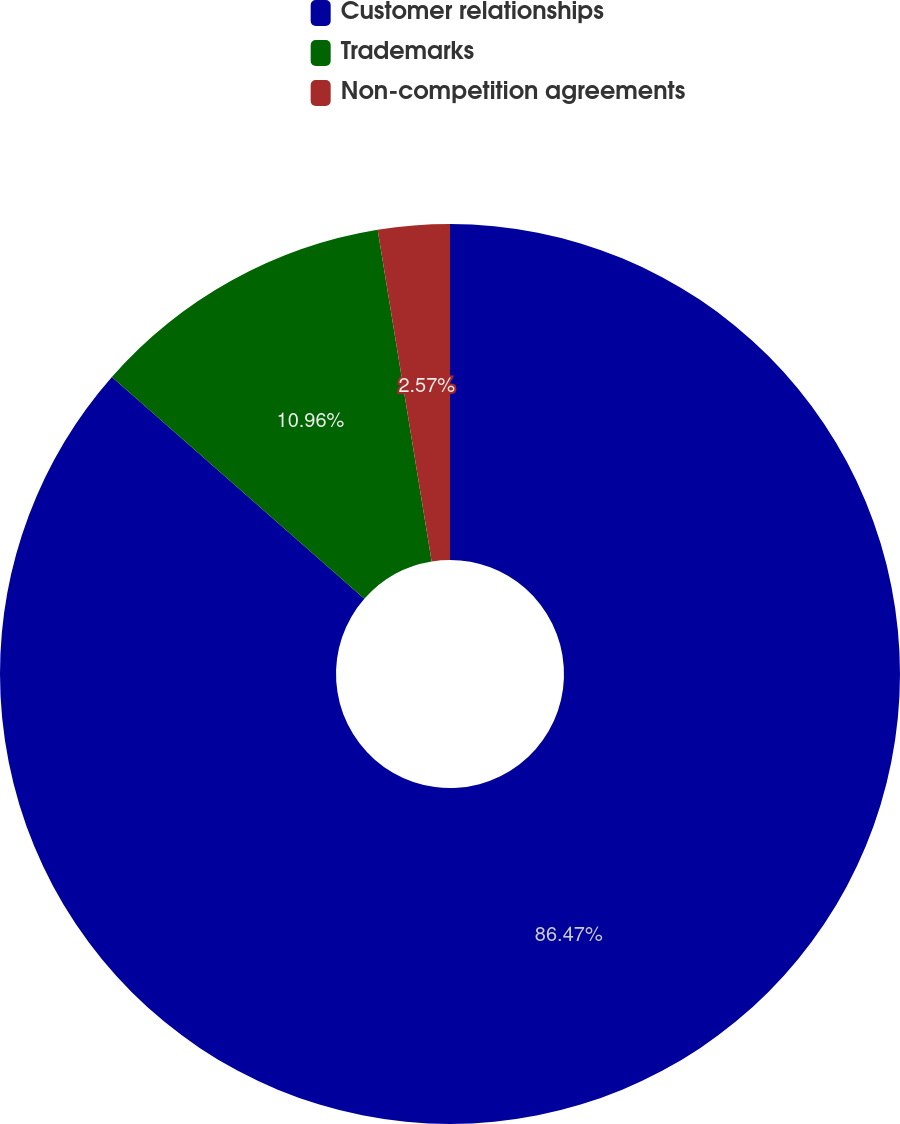Convert chart. <chart><loc_0><loc_0><loc_500><loc_500><pie_chart><fcel>Customer relationships<fcel>Trademarks<fcel>Non-competition agreements<nl><fcel>86.47%<fcel>10.96%<fcel>2.57%<nl></chart> 